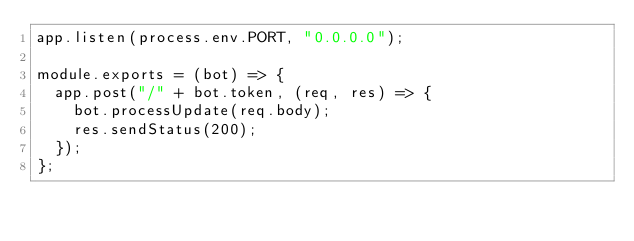<code> <loc_0><loc_0><loc_500><loc_500><_JavaScript_>app.listen(process.env.PORT, "0.0.0.0");

module.exports = (bot) => {
  app.post("/" + bot.token, (req, res) => {
    bot.processUpdate(req.body);
    res.sendStatus(200);
  });
};</code> 